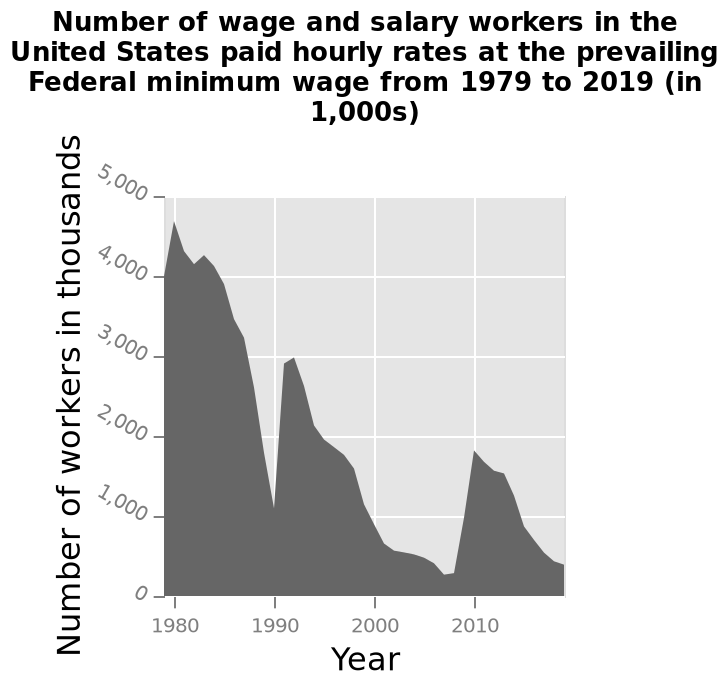<image>
What is the title of the area diagram? The area diagram is titled "Number of wage and salary workers in the United States paid hourly rates at the prevailing Federal minimum wage from 1979 to 2019 (in 1,000s)". What was the number of wage and salary workers in the US paid hourly rates at the minimum wage in 2019?  300,000 